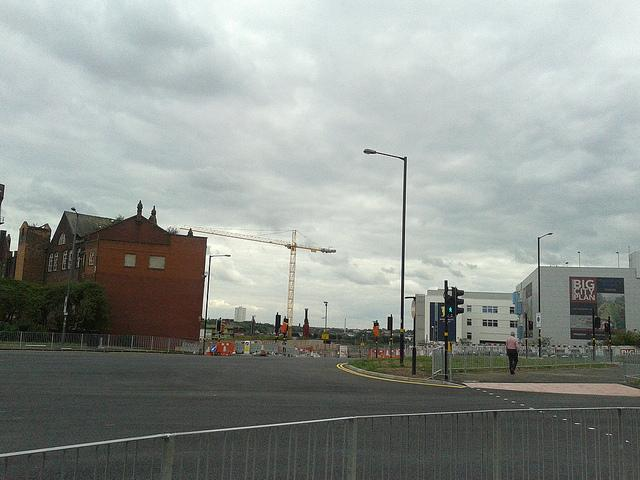What is the yellow structure in the background used for? Please explain your reasoning. lifting things. The yellow structure is a crane. it can be used to move objects from the ground to higher heights. 